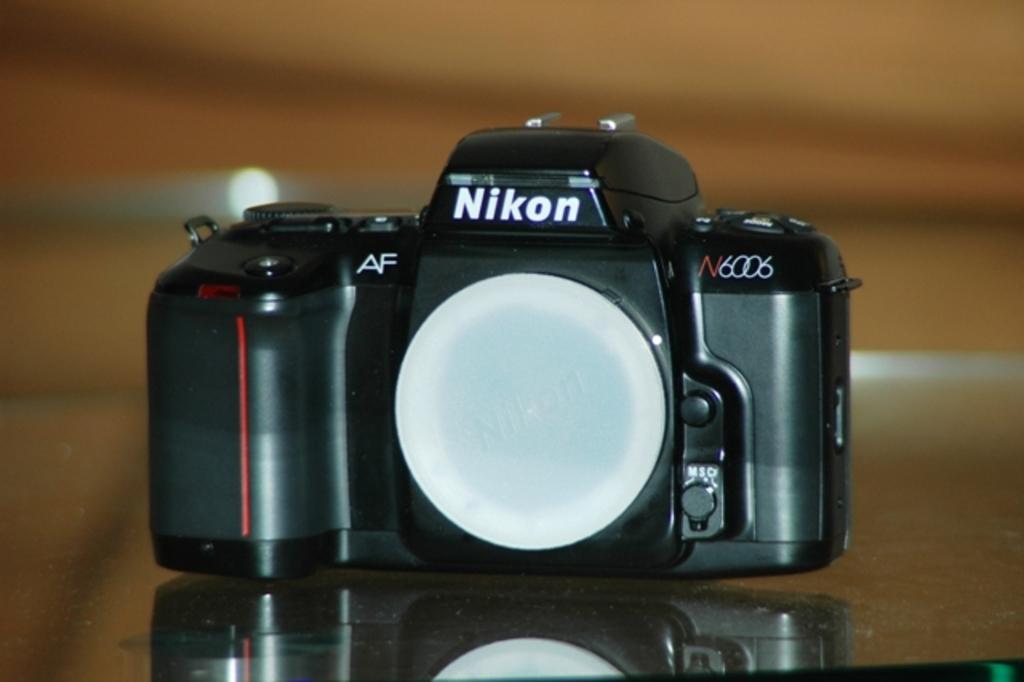What series of nikon is this?
Give a very brief answer. N6006. What brand of camera is this?
Offer a very short reply. Nikon. 